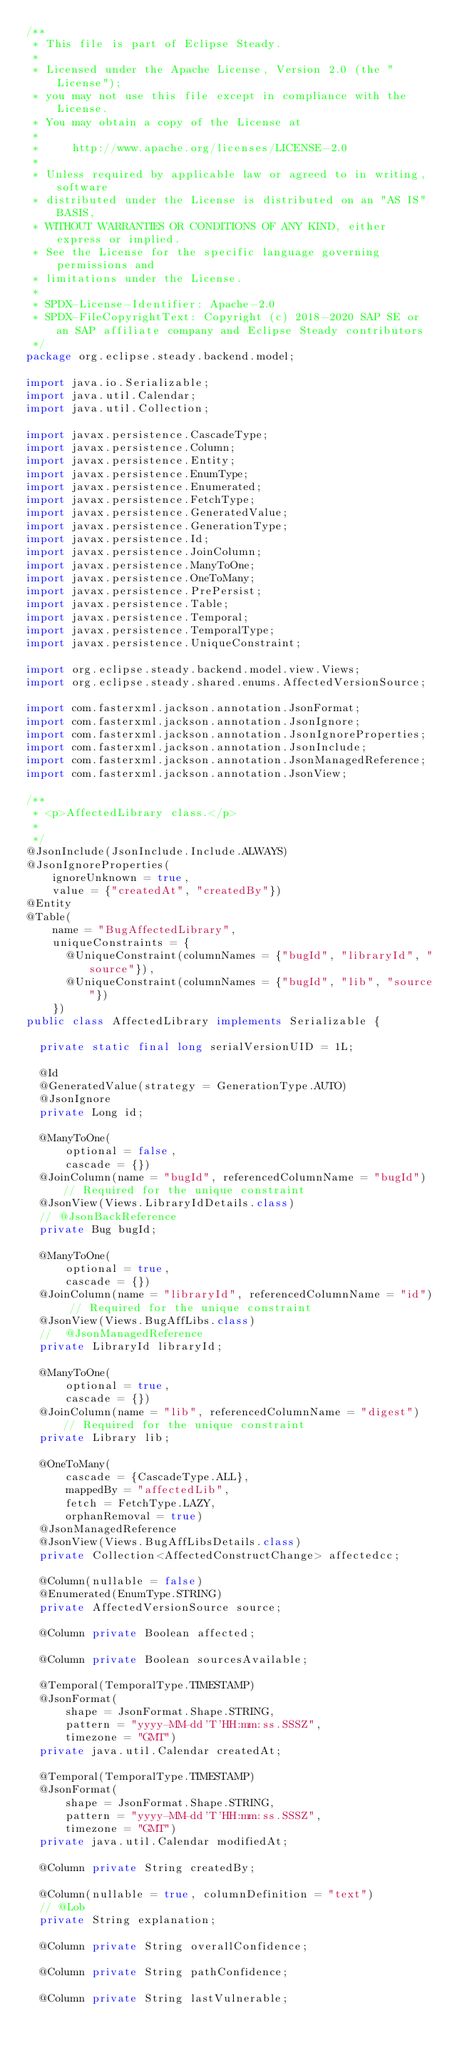<code> <loc_0><loc_0><loc_500><loc_500><_Java_>/**
 * This file is part of Eclipse Steady.
 *
 * Licensed under the Apache License, Version 2.0 (the "License");
 * you may not use this file except in compliance with the License.
 * You may obtain a copy of the License at
 *
 *     http://www.apache.org/licenses/LICENSE-2.0
 *
 * Unless required by applicable law or agreed to in writing, software
 * distributed under the License is distributed on an "AS IS" BASIS,
 * WITHOUT WARRANTIES OR CONDITIONS OF ANY KIND, either express or implied.
 * See the License for the specific language governing permissions and
 * limitations under the License.
 *
 * SPDX-License-Identifier: Apache-2.0
 * SPDX-FileCopyrightText: Copyright (c) 2018-2020 SAP SE or an SAP affiliate company and Eclipse Steady contributors
 */
package org.eclipse.steady.backend.model;

import java.io.Serializable;
import java.util.Calendar;
import java.util.Collection;

import javax.persistence.CascadeType;
import javax.persistence.Column;
import javax.persistence.Entity;
import javax.persistence.EnumType;
import javax.persistence.Enumerated;
import javax.persistence.FetchType;
import javax.persistence.GeneratedValue;
import javax.persistence.GenerationType;
import javax.persistence.Id;
import javax.persistence.JoinColumn;
import javax.persistence.ManyToOne;
import javax.persistence.OneToMany;
import javax.persistence.PrePersist;
import javax.persistence.Table;
import javax.persistence.Temporal;
import javax.persistence.TemporalType;
import javax.persistence.UniqueConstraint;

import org.eclipse.steady.backend.model.view.Views;
import org.eclipse.steady.shared.enums.AffectedVersionSource;

import com.fasterxml.jackson.annotation.JsonFormat;
import com.fasterxml.jackson.annotation.JsonIgnore;
import com.fasterxml.jackson.annotation.JsonIgnoreProperties;
import com.fasterxml.jackson.annotation.JsonInclude;
import com.fasterxml.jackson.annotation.JsonManagedReference;
import com.fasterxml.jackson.annotation.JsonView;

/**
 * <p>AffectedLibrary class.</p>
 *
 */
@JsonInclude(JsonInclude.Include.ALWAYS)
@JsonIgnoreProperties(
    ignoreUnknown = true,
    value = {"createdAt", "createdBy"})
@Entity
@Table(
    name = "BugAffectedLibrary",
    uniqueConstraints = {
      @UniqueConstraint(columnNames = {"bugId", "libraryId", "source"}),
      @UniqueConstraint(columnNames = {"bugId", "lib", "source"})
    })
public class AffectedLibrary implements Serializable {

  private static final long serialVersionUID = 1L;

  @Id
  @GeneratedValue(strategy = GenerationType.AUTO)
  @JsonIgnore
  private Long id;

  @ManyToOne(
      optional = false,
      cascade = {})
  @JoinColumn(name = "bugId", referencedColumnName = "bugId") // Required for the unique constraint
  @JsonView(Views.LibraryIdDetails.class)
  // @JsonBackReference
  private Bug bugId;

  @ManyToOne(
      optional = true,
      cascade = {})
  @JoinColumn(name = "libraryId", referencedColumnName = "id") // Required for the unique constraint
  @JsonView(Views.BugAffLibs.class)
  //	@JsonManagedReference
  private LibraryId libraryId;

  @ManyToOne(
      optional = true,
      cascade = {})
  @JoinColumn(name = "lib", referencedColumnName = "digest") // Required for the unique constraint
  private Library lib;

  @OneToMany(
      cascade = {CascadeType.ALL},
      mappedBy = "affectedLib",
      fetch = FetchType.LAZY,
      orphanRemoval = true)
  @JsonManagedReference
  @JsonView(Views.BugAffLibsDetails.class)
  private Collection<AffectedConstructChange> affectedcc;

  @Column(nullable = false)
  @Enumerated(EnumType.STRING)
  private AffectedVersionSource source;

  @Column private Boolean affected;

  @Column private Boolean sourcesAvailable;

  @Temporal(TemporalType.TIMESTAMP)
  @JsonFormat(
      shape = JsonFormat.Shape.STRING,
      pattern = "yyyy-MM-dd'T'HH:mm:ss.SSSZ",
      timezone = "GMT")
  private java.util.Calendar createdAt;

  @Temporal(TemporalType.TIMESTAMP)
  @JsonFormat(
      shape = JsonFormat.Shape.STRING,
      pattern = "yyyy-MM-dd'T'HH:mm:ss.SSSZ",
      timezone = "GMT")
  private java.util.Calendar modifiedAt;

  @Column private String createdBy;

  @Column(nullable = true, columnDefinition = "text")
  // @Lob
  private String explanation;

  @Column private String overallConfidence;

  @Column private String pathConfidence;

  @Column private String lastVulnerable;
</code> 